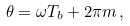<formula> <loc_0><loc_0><loc_500><loc_500>\theta = \omega T _ { b } + 2 \pi m \, ,</formula> 